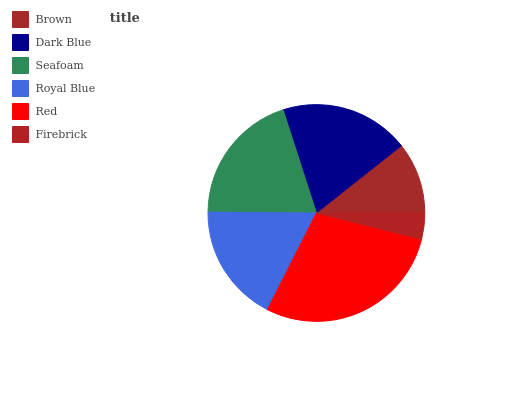Is Firebrick the minimum?
Answer yes or no. Yes. Is Red the maximum?
Answer yes or no. Yes. Is Dark Blue the minimum?
Answer yes or no. No. Is Dark Blue the maximum?
Answer yes or no. No. Is Dark Blue greater than Brown?
Answer yes or no. Yes. Is Brown less than Dark Blue?
Answer yes or no. Yes. Is Brown greater than Dark Blue?
Answer yes or no. No. Is Dark Blue less than Brown?
Answer yes or no. No. Is Dark Blue the high median?
Answer yes or no. Yes. Is Royal Blue the low median?
Answer yes or no. Yes. Is Royal Blue the high median?
Answer yes or no. No. Is Dark Blue the low median?
Answer yes or no. No. 